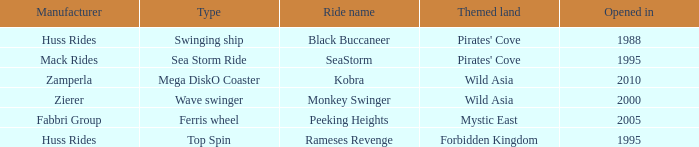Which ride opened after the 2000 Peeking Heights? Ferris wheel. 